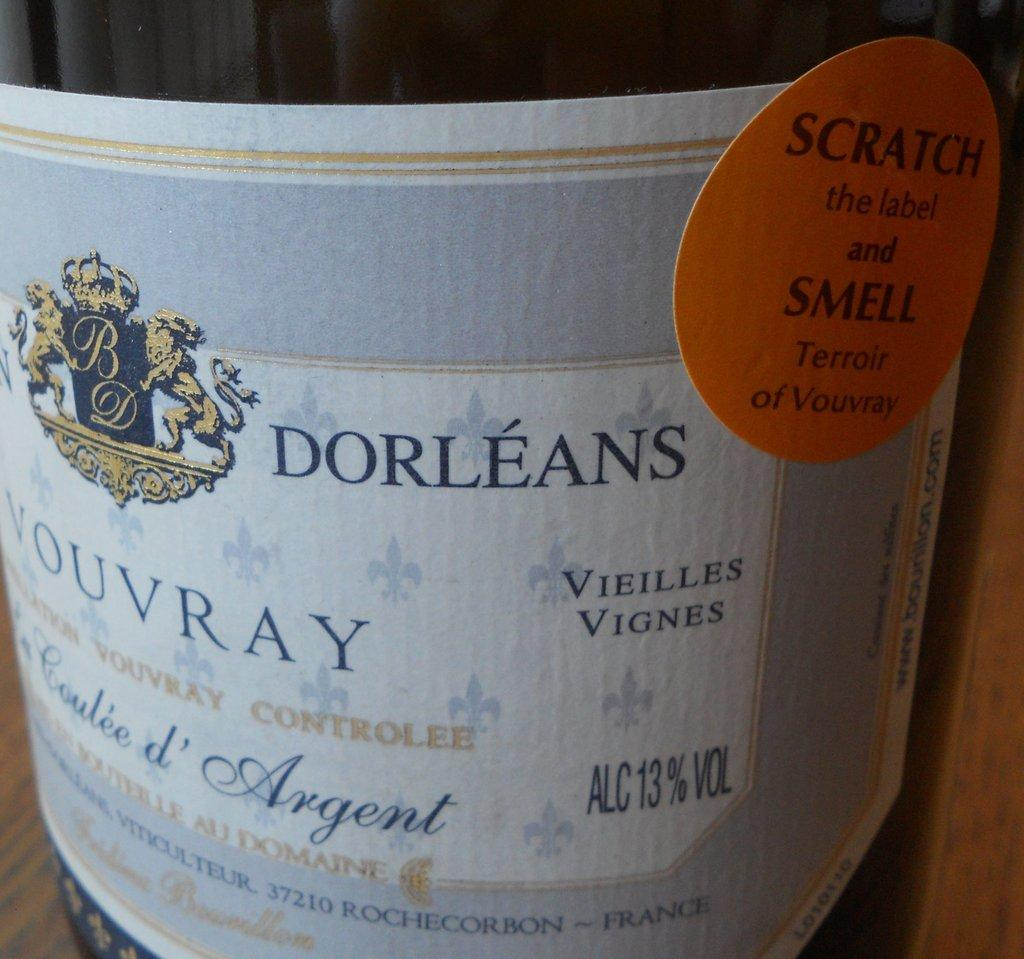<image>
Offer a succinct explanation of the picture presented. A wine bottle features a scratch and sniff label. 